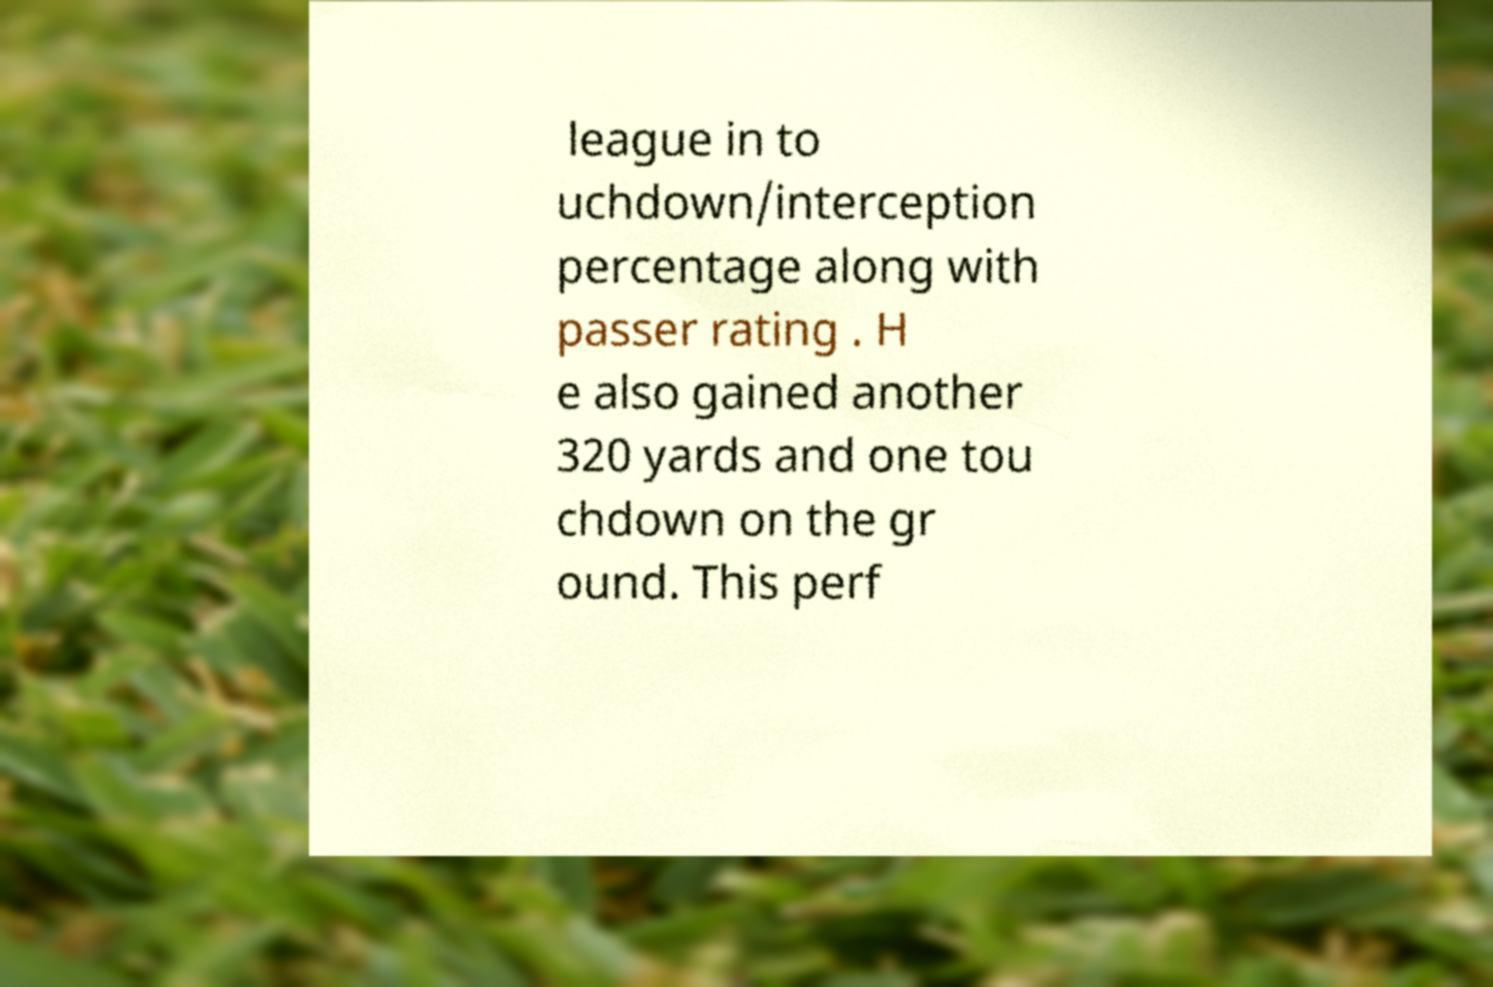There's text embedded in this image that I need extracted. Can you transcribe it verbatim? league in to uchdown/interception percentage along with passer rating . H e also gained another 320 yards and one tou chdown on the gr ound. This perf 